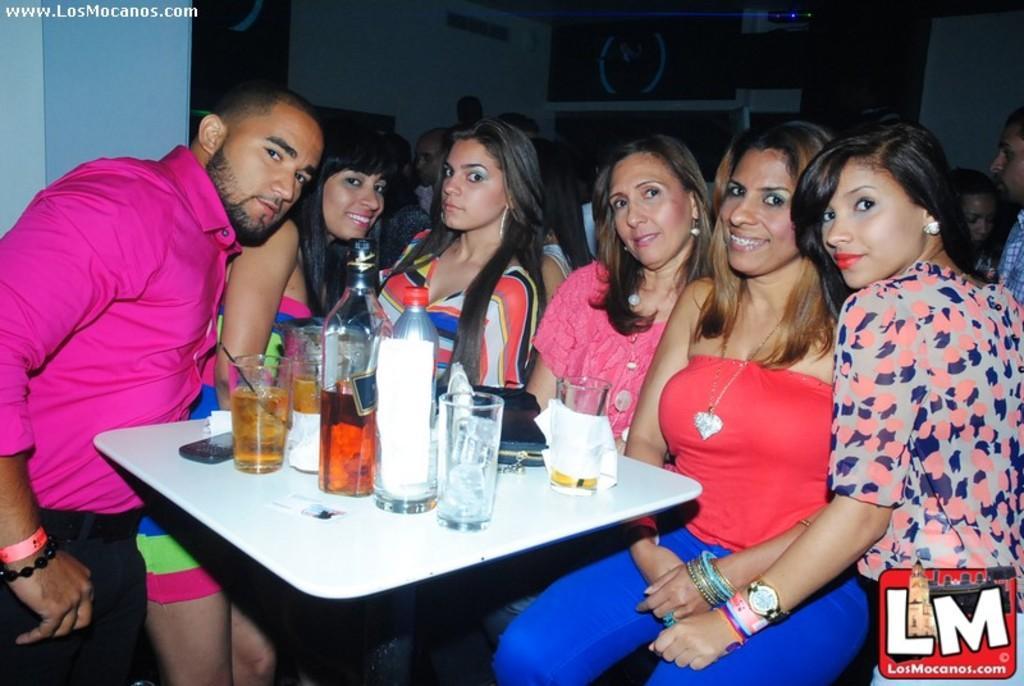In one or two sentences, can you explain what this image depicts? In this image we can see this people are sitting near the table. There are glasses with drink, bottles, mobile phone, bag and tissues on the table. This people are standing. 